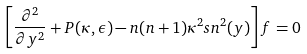Convert formula to latex. <formula><loc_0><loc_0><loc_500><loc_500>\left [ \frac { \partial ^ { 2 } } { \partial y ^ { 2 } } + P ( \kappa , \epsilon ) - n ( n + 1 ) \kappa ^ { 2 } s n ^ { 2 } ( y ) \right ] f = 0</formula> 